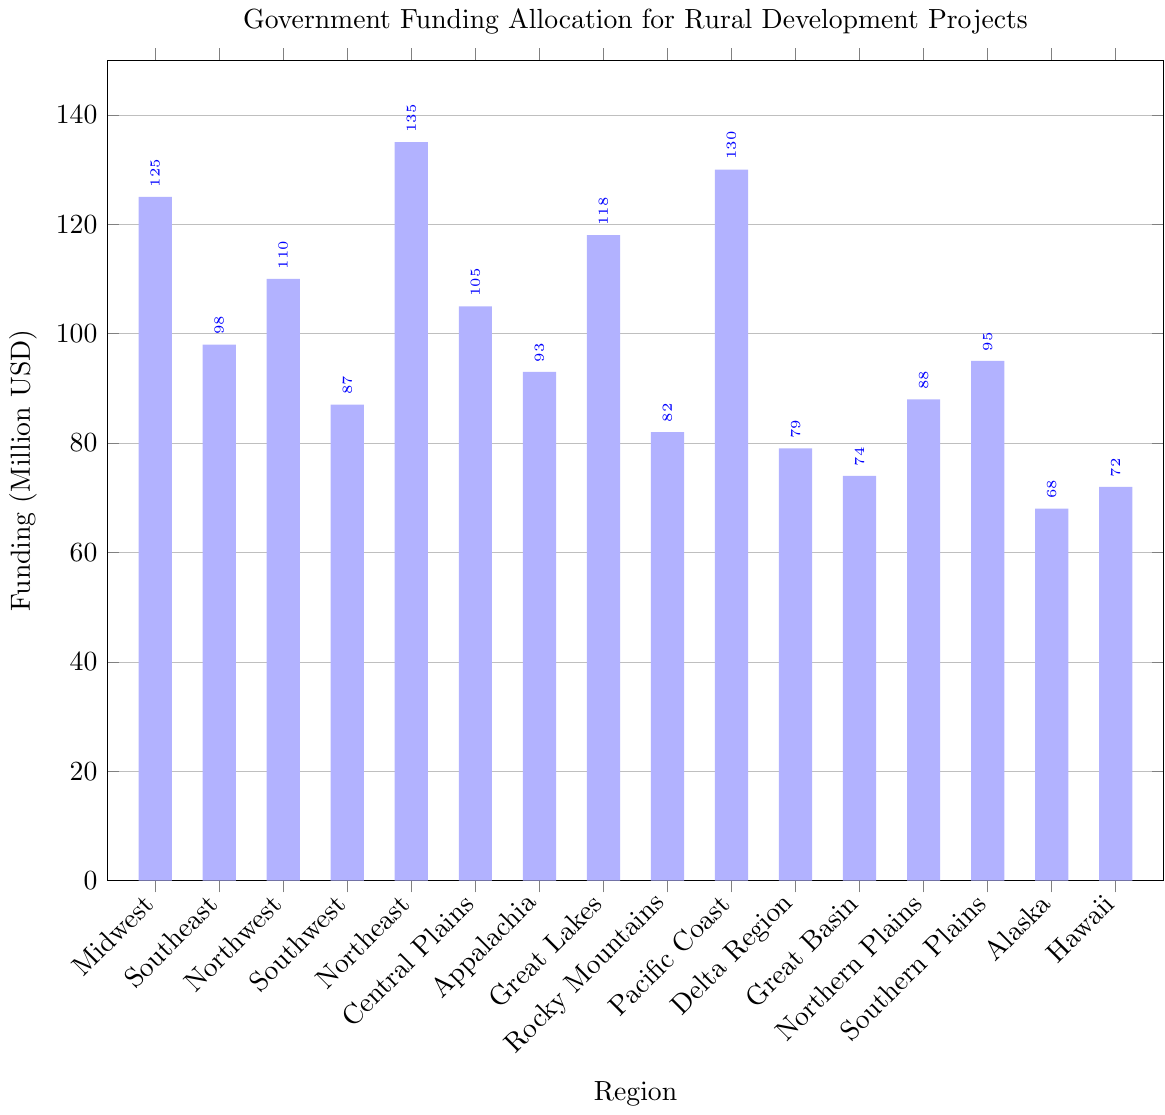What's the region with the highest government funding allocation for rural development projects? From the bar heights, the Northeast region has the tallest bar, indicating the highest funding allocation.
Answer: Northeast Which regions have funding allocations greater than 100 million USD? Identifying the bars taller than 100 on the y-axis, the regions are Midwest, Northeast, Pacific Coast, Northwest, Great Lakes, and Central Plains.
Answer: Midwest, Northeast, Pacific Coast, Northwest, Great Lakes, Central Plains What is the difference in funding allocation between Midwest and Southeast? The Midwest has 125 million USD and the Southeast has 98 million USD. The difference is calculated as 125 minus 98.
Answer: 27 million USD Which two regions have the lowest funding allocation? Reviewing the heights of the bars, the two shortest bars belong to Alaska and Hawaii.
Answer: Alaska, Hawaii Calculate the average funding allocation for the Midwest, Southeast, and Great Basin regions. The funding allocations are 125, 98, and 74 million USD respectively. The average is calculated as (125 + 98 + 74) divided by 3.
Answer: 99 million USD How many regions have funding allocations between 80 and 100 million USD? Observing the bar heights within the 80 to 100 range, the regions are Southeast, Southwest, Appalachia, Rocky Mountains, Northern Plains, and Southern Plains.
Answer: 6 regions Is the funding allocation for the Central Plains greater than that for Appalachia? Comparing the heights of the bars, the Central Plains have higher funding at 105 million USD compared to Appalachia with 93 million USD.
Answer: Yes Which region's funding allocation is closest to the median funding allocation? Listing the funding amounts in ascending order and finding the middle values: 68, 72, 74, 79, 82, 87, 88, 93, 95, 98, 105, 110, 118, 125, 130, 135. The median is between 93 and 95, making the Southern Plains (95) closest to the median.
Answer: Southern Plains By how much does the funding allocation for the Northeast exceed that for the Delta Region? The Northeast has 135 million USD while the Delta Region has 79 million USD. The difference is calculated as 135 minus 79.
Answer: 56 million USD Which region has a funding allocation that is exactly between the amounts allocated to the Great Lakes and Rocky Mountains? The Great Lakes have 118 million USD and the Rocky Mountains have 82 million USD. The midpoint is (118+82)/2 = 100 million USD. The closest region is the Southeast, which has 98 million USD.
Answer: Southeast 